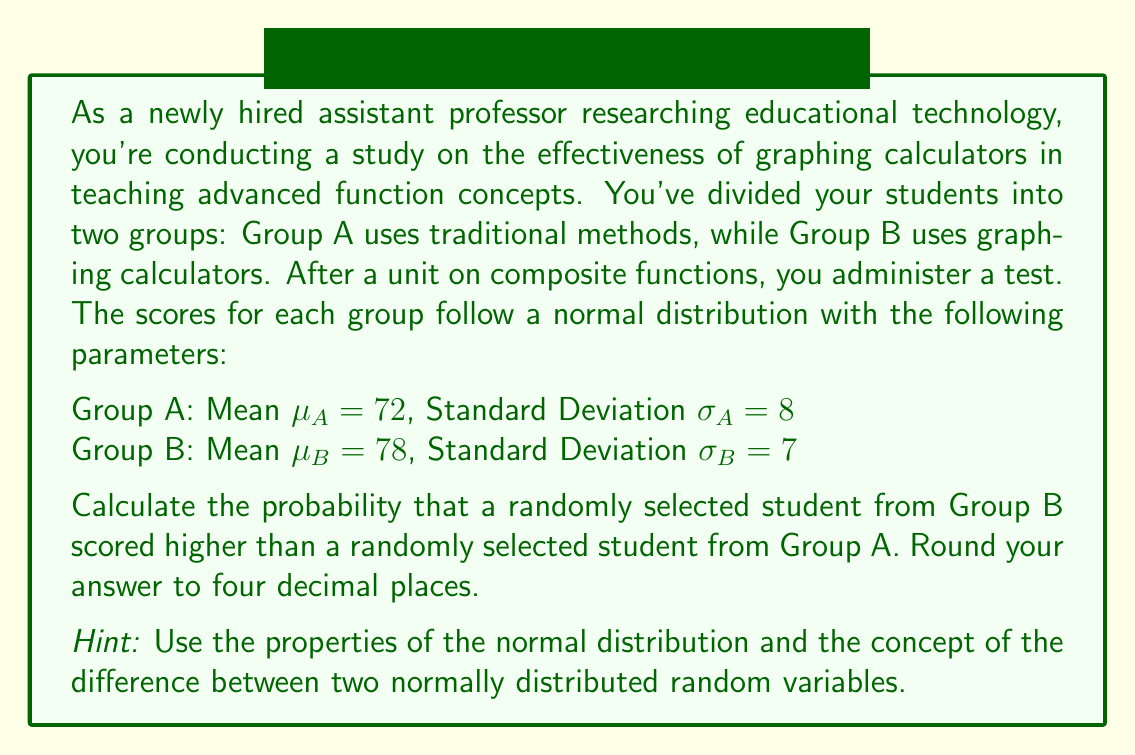Could you help me with this problem? To solve this problem, we'll follow these steps:

1) Let $X_A$ be the score of a random student from Group A, and $X_B$ be the score of a random student from Group B.

2) We want to find $P(X_B > X_A)$, which is equivalent to $P(X_B - X_A > 0)$.

3) The difference between two normally distributed random variables is also normally distributed. The mean of the difference is the difference of the means, and the variance of the difference is the sum of the variances. So:

   $X_B - X_A \sim N(\mu_B - \mu_A, \sqrt{\sigma_B^2 + \sigma_A^2})$

4) Calculate the mean of the difference:
   $\mu_{B-A} = \mu_B - \mu_A = 78 - 72 = 6$

5) Calculate the standard deviation of the difference:
   $\sigma_{B-A} = \sqrt{\sigma_B^2 + \sigma_A^2} = \sqrt{7^2 + 8^2} = \sqrt{113} \approx 10.63$

6) Now, we need to find $P(X_B - X_A > 0)$, which is equivalent to finding the area under the standard normal curve to the right of $z = \frac{0 - \mu_{B-A}}{\sigma_{B-A}}$

7) Calculate z:
   $z = \frac{0 - 6}{10.63} \approx -0.5643$

8) Using a standard normal table or calculator, find the area to the right of z = -0.5643.
   This is equal to 1 - Φ(-0.5643), where Φ is the cumulative distribution function of the standard normal distribution.

9) 1 - Φ(-0.5643) ≈ 0.7137

Therefore, the probability that a randomly selected student from Group B scored higher than a randomly selected student from Group A is approximately 0.7137 or 71.37%.
Answer: 0.7137 